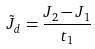Convert formula to latex. <formula><loc_0><loc_0><loc_500><loc_500>\tilde { J } _ { d } = \frac { J _ { 2 } - J _ { 1 } } { t _ { 1 } }</formula> 